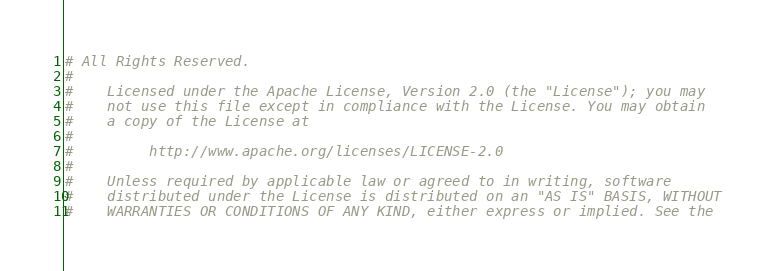<code> <loc_0><loc_0><loc_500><loc_500><_Python_># All Rights Reserved.
#
#    Licensed under the Apache License, Version 2.0 (the "License"); you may
#    not use this file except in compliance with the License. You may obtain
#    a copy of the License at
#
#         http://www.apache.org/licenses/LICENSE-2.0
#
#    Unless required by applicable law or agreed to in writing, software
#    distributed under the License is distributed on an "AS IS" BASIS, WITHOUT
#    WARRANTIES OR CONDITIONS OF ANY KIND, either express or implied. See the</code> 